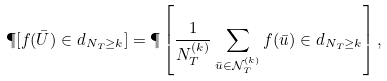Convert formula to latex. <formula><loc_0><loc_0><loc_500><loc_500>\P [ f ( \bar { U } ) \in d _ { N _ { T } \geq k } ] = \P \left [ \frac { 1 } { N _ { T } ^ { ( k ) } } \sum _ { \bar { u } \in \mathcal { N } _ { T } ^ { ( k ) } } f ( \bar { u } ) \in d _ { N _ { T } \geq k } \right ] ,</formula> 